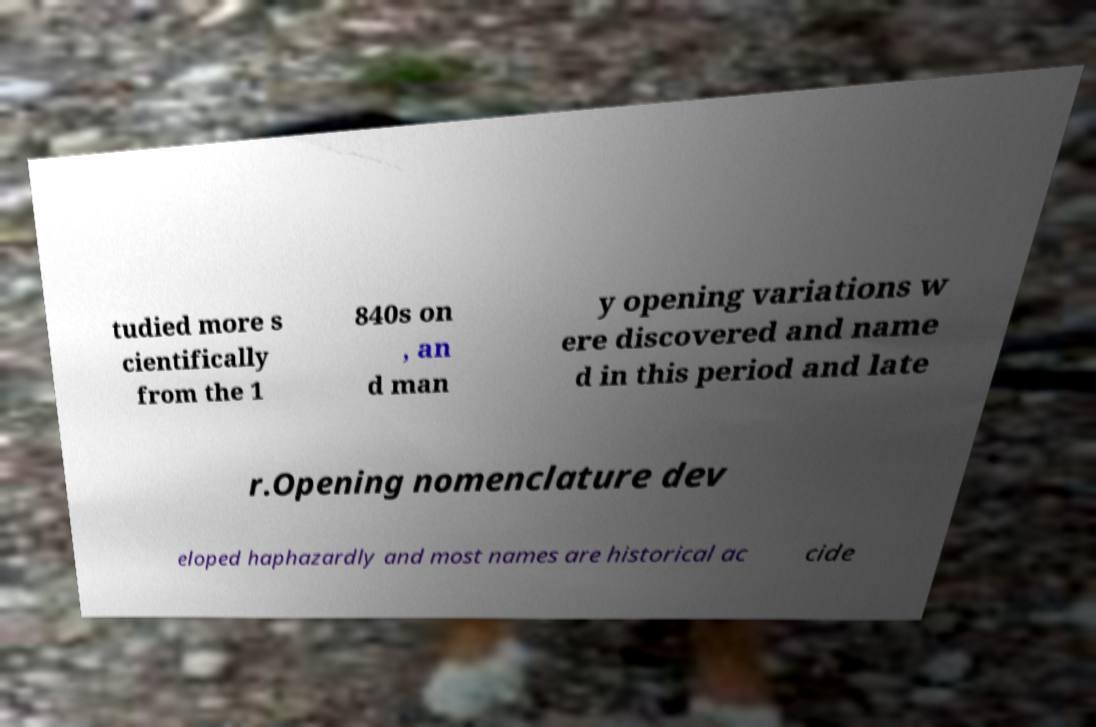Please read and relay the text visible in this image. What does it say? tudied more s cientifically from the 1 840s on , an d man y opening variations w ere discovered and name d in this period and late r.Opening nomenclature dev eloped haphazardly and most names are historical ac cide 